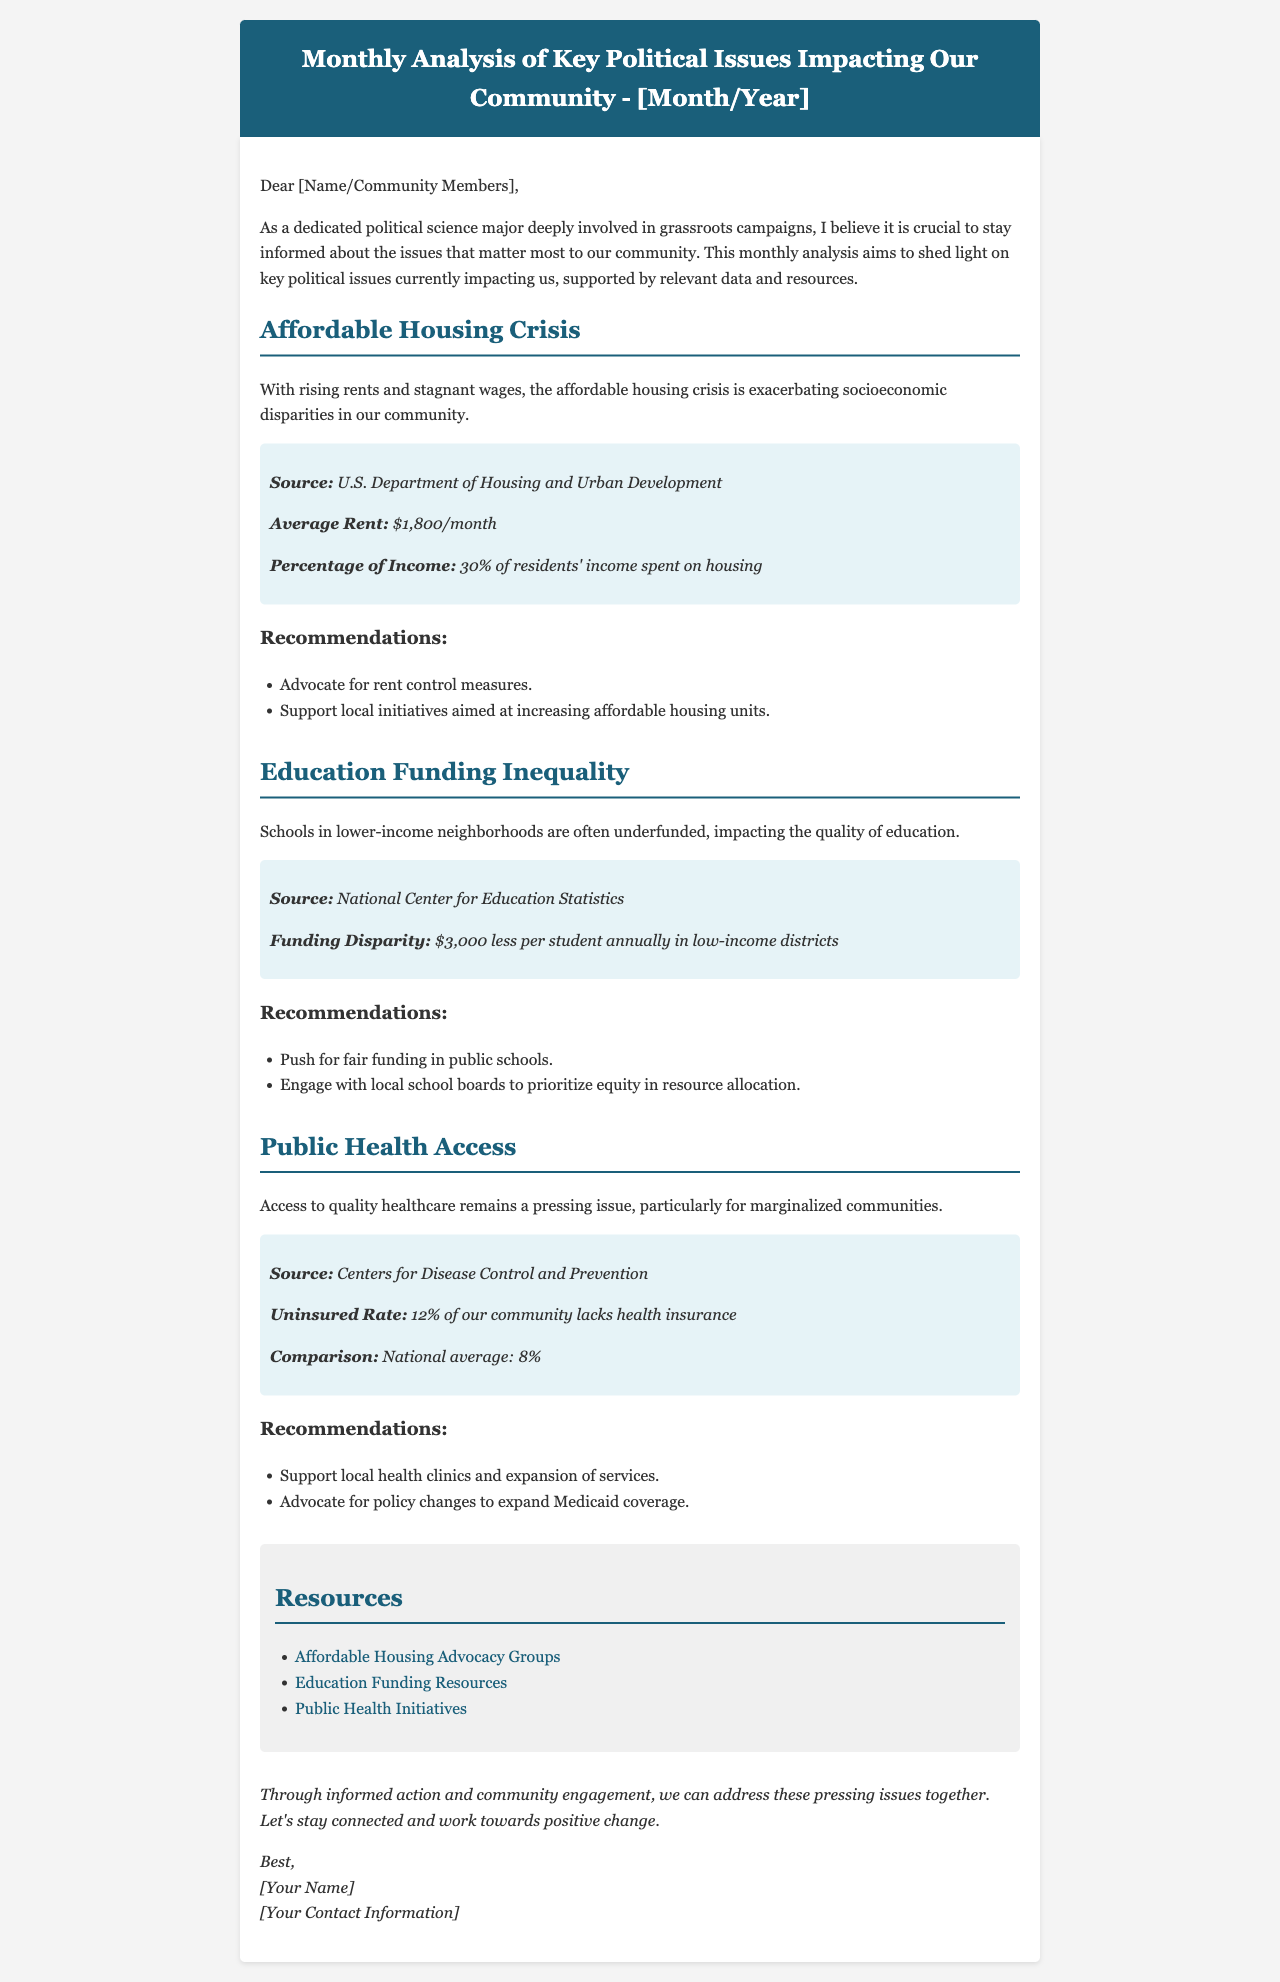What is the average rent in the community? The average rent is mentioned in the context of the affordable housing crisis, which states it is $1,800/month.
Answer: $1,800/month What percentage of residents' income is spent on housing? The document indicates that 30% of residents' income is spent on housing.
Answer: 30% How much less funding do schools in low-income districts receive annually per student? The funding disparity in low-income districts is specified as $3,000 less per student annually.
Answer: $3,000 What is the uninsured rate in the community? The document states that the uninsured rate of our community is 12%.
Answer: 12% What are two recommendations for addressing the affordable housing crisis? The recommendations listed for this issue include advocating for rent control measures and supporting local initiatives for affordable housing.
Answer: Advocate for rent control measures; support local initiatives What is the source for the public health access statistics? The source of the public health access statistics is mentioned as the Centers for Disease Control and Prevention.
Answer: Centers for Disease Control and Prevention How can community members support local health clinics according to the document? One of the recommendations given for public health access is to support local health clinics and the expansion of services.
Answer: Support local health clinics Which organizations are provided as resources for affordable housing advocacy? The document lists a specific link to affordable housing advocacy groups as a resource.
Answer: Affordable Housing Advocacy Groups What is the main topic of this monthly analysis? The overall subject of the email is the analysis of key political issues impacting the community.
Answer: Key political issues impacting the community 